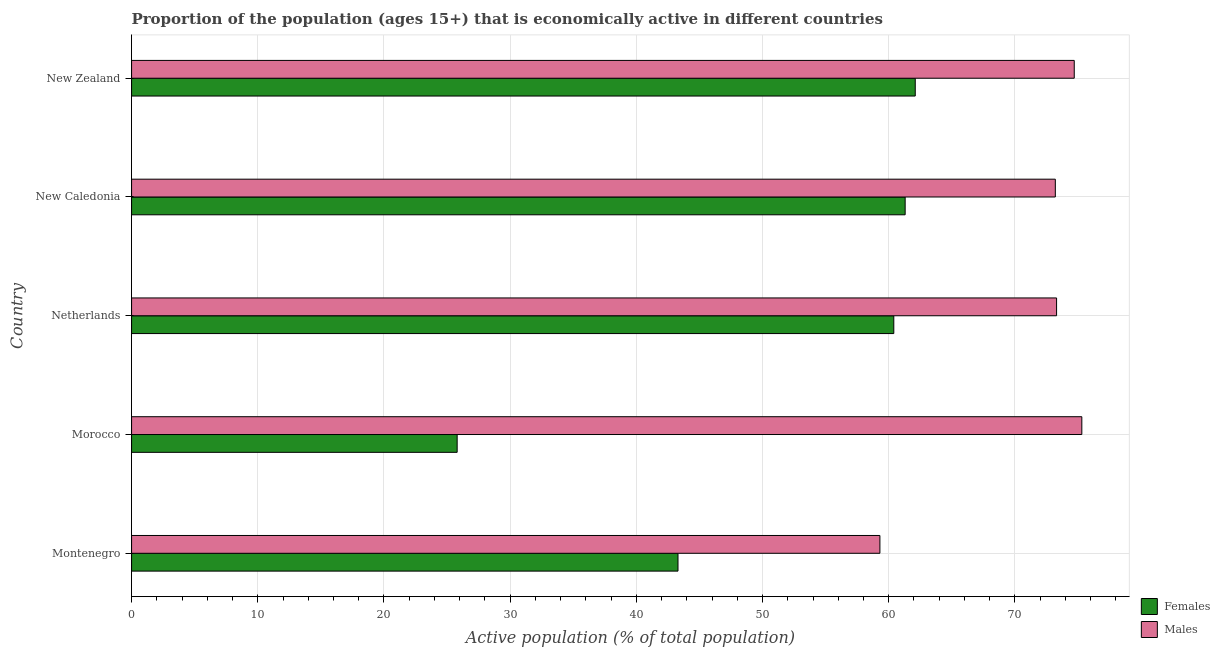How many different coloured bars are there?
Your response must be concise. 2. How many bars are there on the 5th tick from the top?
Offer a terse response. 2. What is the label of the 1st group of bars from the top?
Your answer should be very brief. New Zealand. What is the percentage of economically active female population in Montenegro?
Keep it short and to the point. 43.3. Across all countries, what is the maximum percentage of economically active female population?
Your answer should be compact. 62.1. Across all countries, what is the minimum percentage of economically active male population?
Give a very brief answer. 59.3. In which country was the percentage of economically active female population maximum?
Your answer should be compact. New Zealand. In which country was the percentage of economically active male population minimum?
Ensure brevity in your answer.  Montenegro. What is the total percentage of economically active female population in the graph?
Offer a terse response. 252.9. What is the difference between the percentage of economically active male population in Montenegro and the percentage of economically active female population in New Zealand?
Give a very brief answer. -2.8. What is the average percentage of economically active male population per country?
Your answer should be very brief. 71.16. What is the difference between the percentage of economically active male population and percentage of economically active female population in New Zealand?
Make the answer very short. 12.6. In how many countries, is the percentage of economically active female population greater than 64 %?
Offer a very short reply. 0. What is the ratio of the percentage of economically active male population in Montenegro to that in New Zealand?
Make the answer very short. 0.79. Is the percentage of economically active male population in Morocco less than that in New Caledonia?
Give a very brief answer. No. What is the difference between the highest and the second highest percentage of economically active male population?
Ensure brevity in your answer.  0.6. What does the 2nd bar from the top in Montenegro represents?
Ensure brevity in your answer.  Females. What does the 1st bar from the bottom in Montenegro represents?
Keep it short and to the point. Females. Are all the bars in the graph horizontal?
Ensure brevity in your answer.  Yes. How many countries are there in the graph?
Provide a succinct answer. 5. Are the values on the major ticks of X-axis written in scientific E-notation?
Offer a terse response. No. Does the graph contain any zero values?
Your response must be concise. No. Does the graph contain grids?
Keep it short and to the point. Yes. What is the title of the graph?
Offer a very short reply. Proportion of the population (ages 15+) that is economically active in different countries. What is the label or title of the X-axis?
Provide a succinct answer. Active population (% of total population). What is the label or title of the Y-axis?
Make the answer very short. Country. What is the Active population (% of total population) in Females in Montenegro?
Provide a short and direct response. 43.3. What is the Active population (% of total population) in Males in Montenegro?
Give a very brief answer. 59.3. What is the Active population (% of total population) of Females in Morocco?
Give a very brief answer. 25.8. What is the Active population (% of total population) in Males in Morocco?
Your answer should be compact. 75.3. What is the Active population (% of total population) of Females in Netherlands?
Offer a very short reply. 60.4. What is the Active population (% of total population) of Males in Netherlands?
Your answer should be compact. 73.3. What is the Active population (% of total population) in Females in New Caledonia?
Your answer should be compact. 61.3. What is the Active population (% of total population) in Males in New Caledonia?
Your answer should be very brief. 73.2. What is the Active population (% of total population) in Females in New Zealand?
Provide a short and direct response. 62.1. What is the Active population (% of total population) in Males in New Zealand?
Your answer should be compact. 74.7. Across all countries, what is the maximum Active population (% of total population) in Females?
Ensure brevity in your answer.  62.1. Across all countries, what is the maximum Active population (% of total population) of Males?
Give a very brief answer. 75.3. Across all countries, what is the minimum Active population (% of total population) of Females?
Make the answer very short. 25.8. Across all countries, what is the minimum Active population (% of total population) of Males?
Make the answer very short. 59.3. What is the total Active population (% of total population) of Females in the graph?
Keep it short and to the point. 252.9. What is the total Active population (% of total population) in Males in the graph?
Your answer should be very brief. 355.8. What is the difference between the Active population (% of total population) in Females in Montenegro and that in Morocco?
Offer a very short reply. 17.5. What is the difference between the Active population (% of total population) in Males in Montenegro and that in Morocco?
Keep it short and to the point. -16. What is the difference between the Active population (% of total population) in Females in Montenegro and that in Netherlands?
Offer a very short reply. -17.1. What is the difference between the Active population (% of total population) of Males in Montenegro and that in New Caledonia?
Offer a terse response. -13.9. What is the difference between the Active population (% of total population) of Females in Montenegro and that in New Zealand?
Make the answer very short. -18.8. What is the difference between the Active population (% of total population) in Males in Montenegro and that in New Zealand?
Keep it short and to the point. -15.4. What is the difference between the Active population (% of total population) in Females in Morocco and that in Netherlands?
Offer a terse response. -34.6. What is the difference between the Active population (% of total population) in Females in Morocco and that in New Caledonia?
Give a very brief answer. -35.5. What is the difference between the Active population (% of total population) of Males in Morocco and that in New Caledonia?
Your response must be concise. 2.1. What is the difference between the Active population (% of total population) in Females in Morocco and that in New Zealand?
Provide a succinct answer. -36.3. What is the difference between the Active population (% of total population) in Males in Morocco and that in New Zealand?
Make the answer very short. 0.6. What is the difference between the Active population (% of total population) in Females in Netherlands and that in New Caledonia?
Offer a terse response. -0.9. What is the difference between the Active population (% of total population) of Females in New Caledonia and that in New Zealand?
Your answer should be compact. -0.8. What is the difference between the Active population (% of total population) of Females in Montenegro and the Active population (% of total population) of Males in Morocco?
Your answer should be compact. -32. What is the difference between the Active population (% of total population) of Females in Montenegro and the Active population (% of total population) of Males in Netherlands?
Offer a very short reply. -30. What is the difference between the Active population (% of total population) of Females in Montenegro and the Active population (% of total population) of Males in New Caledonia?
Offer a terse response. -29.9. What is the difference between the Active population (% of total population) in Females in Montenegro and the Active population (% of total population) in Males in New Zealand?
Provide a short and direct response. -31.4. What is the difference between the Active population (% of total population) of Females in Morocco and the Active population (% of total population) of Males in Netherlands?
Ensure brevity in your answer.  -47.5. What is the difference between the Active population (% of total population) of Females in Morocco and the Active population (% of total population) of Males in New Caledonia?
Offer a very short reply. -47.4. What is the difference between the Active population (% of total population) of Females in Morocco and the Active population (% of total population) of Males in New Zealand?
Your answer should be compact. -48.9. What is the difference between the Active population (% of total population) in Females in Netherlands and the Active population (% of total population) in Males in New Caledonia?
Your answer should be compact. -12.8. What is the difference between the Active population (% of total population) in Females in Netherlands and the Active population (% of total population) in Males in New Zealand?
Your answer should be compact. -14.3. What is the average Active population (% of total population) of Females per country?
Your answer should be very brief. 50.58. What is the average Active population (% of total population) in Males per country?
Give a very brief answer. 71.16. What is the difference between the Active population (% of total population) of Females and Active population (% of total population) of Males in Morocco?
Keep it short and to the point. -49.5. What is the difference between the Active population (% of total population) in Females and Active population (% of total population) in Males in New Caledonia?
Offer a very short reply. -11.9. What is the ratio of the Active population (% of total population) of Females in Montenegro to that in Morocco?
Offer a very short reply. 1.68. What is the ratio of the Active population (% of total population) of Males in Montenegro to that in Morocco?
Your answer should be very brief. 0.79. What is the ratio of the Active population (% of total population) in Females in Montenegro to that in Netherlands?
Keep it short and to the point. 0.72. What is the ratio of the Active population (% of total population) of Males in Montenegro to that in Netherlands?
Your answer should be very brief. 0.81. What is the ratio of the Active population (% of total population) in Females in Montenegro to that in New Caledonia?
Your answer should be compact. 0.71. What is the ratio of the Active population (% of total population) of Males in Montenegro to that in New Caledonia?
Keep it short and to the point. 0.81. What is the ratio of the Active population (% of total population) in Females in Montenegro to that in New Zealand?
Provide a succinct answer. 0.7. What is the ratio of the Active population (% of total population) of Males in Montenegro to that in New Zealand?
Your answer should be compact. 0.79. What is the ratio of the Active population (% of total population) of Females in Morocco to that in Netherlands?
Offer a terse response. 0.43. What is the ratio of the Active population (% of total population) in Males in Morocco to that in Netherlands?
Provide a short and direct response. 1.03. What is the ratio of the Active population (% of total population) of Females in Morocco to that in New Caledonia?
Ensure brevity in your answer.  0.42. What is the ratio of the Active population (% of total population) in Males in Morocco to that in New Caledonia?
Offer a terse response. 1.03. What is the ratio of the Active population (% of total population) of Females in Morocco to that in New Zealand?
Your answer should be very brief. 0.42. What is the ratio of the Active population (% of total population) of Females in Netherlands to that in New Caledonia?
Ensure brevity in your answer.  0.99. What is the ratio of the Active population (% of total population) of Females in Netherlands to that in New Zealand?
Keep it short and to the point. 0.97. What is the ratio of the Active population (% of total population) of Males in Netherlands to that in New Zealand?
Your response must be concise. 0.98. What is the ratio of the Active population (% of total population) of Females in New Caledonia to that in New Zealand?
Keep it short and to the point. 0.99. What is the ratio of the Active population (% of total population) in Males in New Caledonia to that in New Zealand?
Offer a terse response. 0.98. What is the difference between the highest and the second highest Active population (% of total population) in Males?
Your answer should be very brief. 0.6. What is the difference between the highest and the lowest Active population (% of total population) of Females?
Ensure brevity in your answer.  36.3. What is the difference between the highest and the lowest Active population (% of total population) of Males?
Keep it short and to the point. 16. 